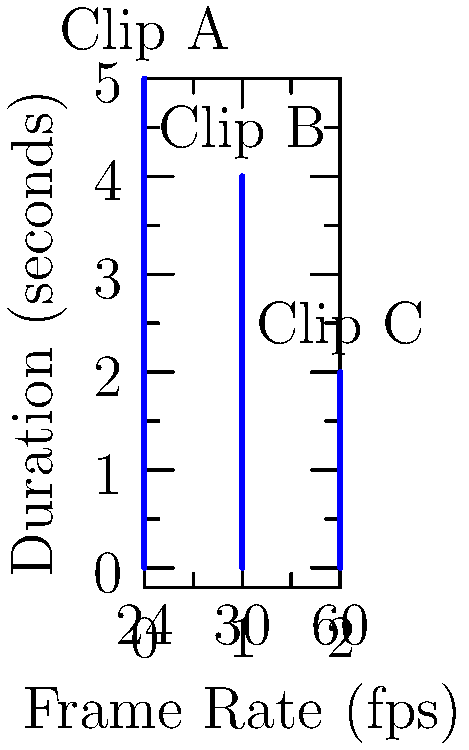As a student filmmaker, you're working on a short film project. You've created three different clips (A, B, and C) with varying frame rates and durations, as shown in the graph. If you need to combine these clips into a single sequence with a consistent frame rate of 30 fps, how many total frames will the final sequence contain? To solve this problem, we need to follow these steps:

1. Calculate the number of frames in each clip:
   
   Clip A: $24 \text{ fps} \times 5 \text{ seconds} = 120 \text{ frames}$
   Clip B: $30 \text{ fps} \times 4 \text{ seconds} = 120 \text{ frames}$
   Clip C: $60 \text{ fps} \times 2 \text{ seconds} = 120 \text{ frames}$

2. For Clip A, we need to adjust the number of frames to match 30 fps:
   
   $120 \text{ frames} \times \frac{30 \text{ fps}}{24 \text{ fps}} = 150 \text{ frames}$

3. For Clip C, we need to adjust the number of frames to match 30 fps:
   
   $120 \text{ frames} \times \frac{30 \text{ fps}}{60 \text{ fps}} = 60 \text{ frames}$

4. Clip B already has 30 fps, so it remains at 120 frames.

5. Sum up the adjusted frame counts:
   
   $150 \text{ frames} + 120 \text{ frames} + 60 \text{ frames} = 330 \text{ frames}$

Therefore, the final sequence will contain 330 frames when combined at 30 fps.
Answer: 330 frames 